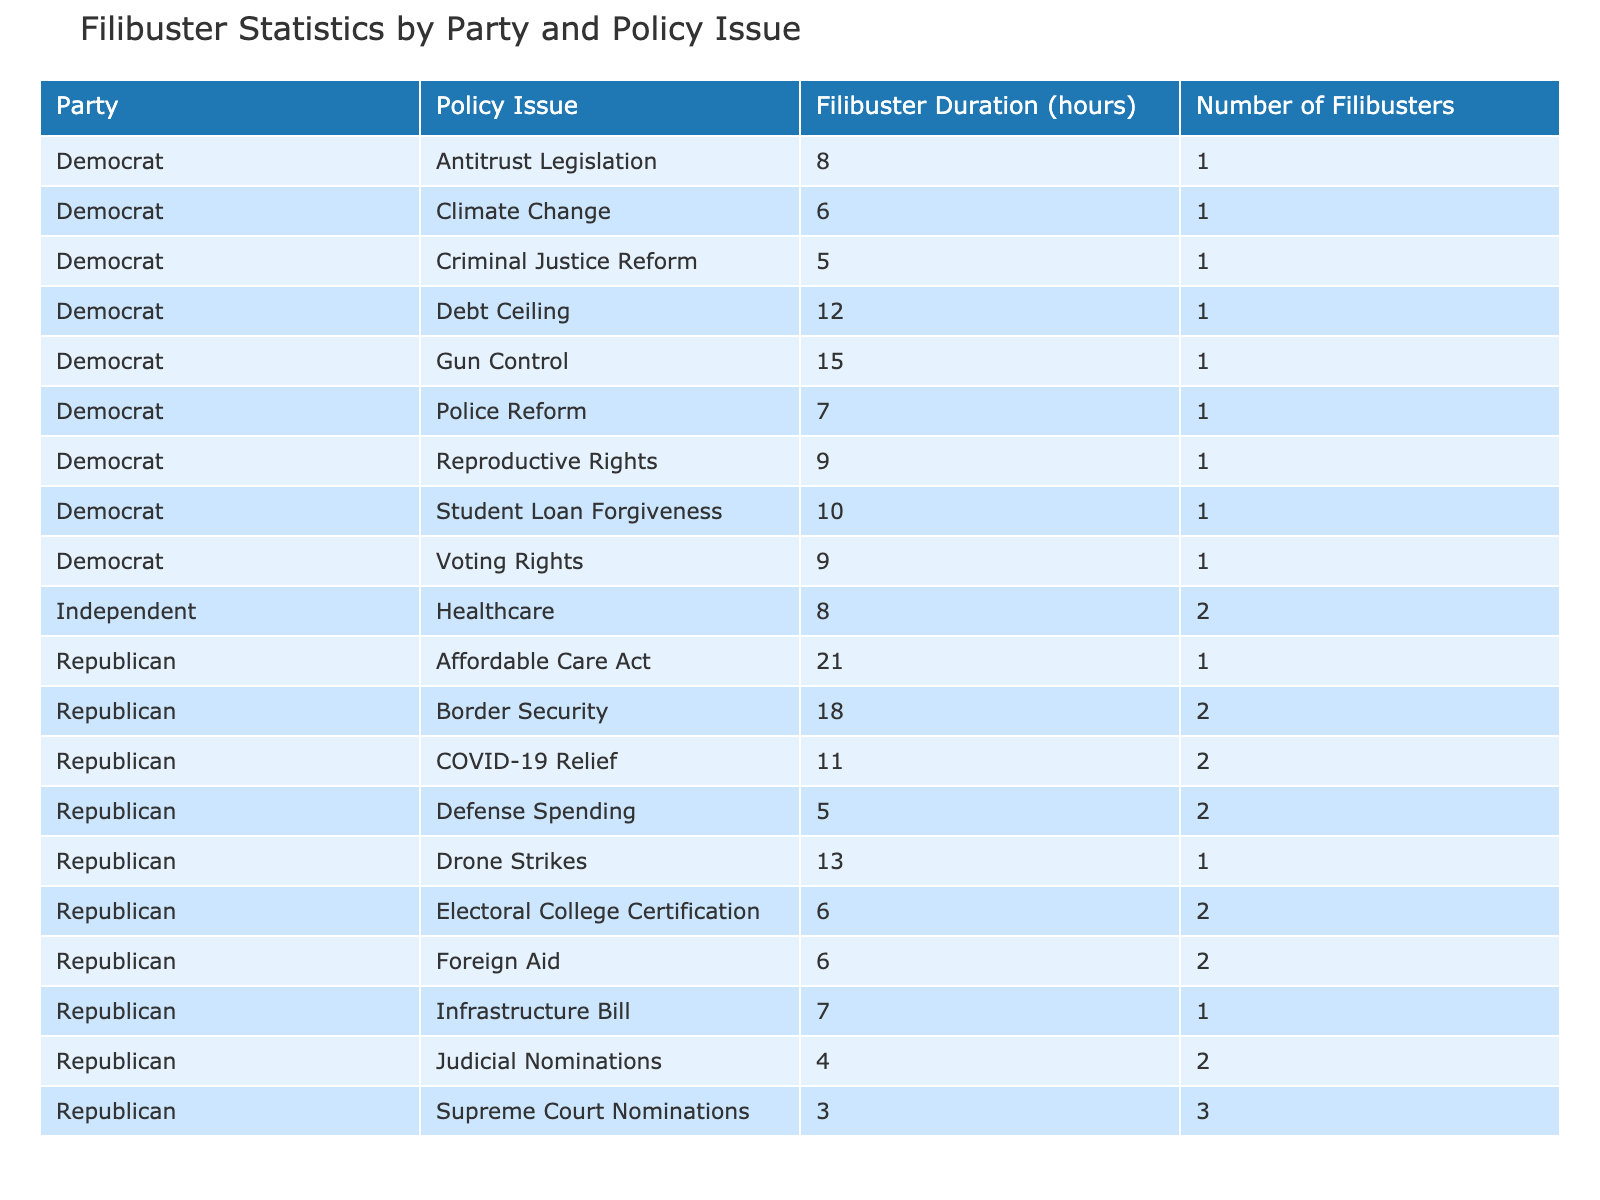What was the total number of filibusters conducted by the Republican Party? Looking at the "Number of Filibusters" column for all rows where the Party is "Republican," we add these values: 1 (Rand Paul) + 1 (Ted Cruz) + 2 (Chuck Grassley) + 3 (Mitch McConnell) + 2 (Rand Paul) + 2 (Ted Cruz) + 2 (John Thune) + 1 (Mike Lee) + 2 (Tom Cotton) = 16.
Answer: 16 What is the average filibuster duration for Democrat-sponsored policy issues? To find the average, we first sum the "Filibuster Duration (hours)" for Democrats: 6 (Jeff Merkley) + 15 (Chris Murphy) + 5 (Cory Booker) + 7 (Kamala Harris) + 9 (Joe Manchin) + 10 (Elizabeth Warren) + 9 (Kirsten Gillibrand) + 8 (Amy Klobuchar) = 69. There are 8 filibusters, so we divide 69 by 8 to get 8.625.
Answer: 8.6 Did the Independent senator conduct more filibusters than the total filibusters conducted by the Democrats? The Independent senator, Bernie Sanders, conducted 2 filibusters. For the Democrats, there were 8 filibusters as calculated before. Since 2 is less than 8, the answer is no.
Answer: No What was the longest filibuster duration for the Republican Party and the corresponding policy issue? From examining the "Filibuster Duration (hours)" for Republicans, the maximum duration is 21 hours for the Affordable Care Act (Ted Cruz).
Answer: 21 hours for Affordable Care Act Which party had the highest total filibuster duration across all policy issues combined? We need to sum the "Filibuster Duration (hours)" for each party. For Republicans: 13 + 21 + 4 + 3 + 11 + 18 + 5 + 7 + 6 = 88 hours. For Democrats: 6 + 15 + 5 + 7 + 9 + 10 + 9 + 8 = 69 hours. Republicans had a total of 88, which is higher than Democrats' 69.
Answer: Republicans How many filibusters did the Democrats conduct on the topic of criminal justice reform? The table shows that Cory Booker (Democrat) conducted 1 filibuster for Criminal Justice Reform.
Answer: 1 What was the average duration of filibusters for the policy issue of Gun Control? There is only one filibuster related to Gun Control by Chris Murphy with a duration of 15 hours. Therefore, the average is also 15.
Answer: 15 Was there any filibuster related to COVID-19 relief by a Democrat senator? The only senator who conducted a filibuster related to COVID-19 Relief was Rand Paul, who is a Republican. Thus, there were no Democrat filibusters on this issue.
Answer: No 